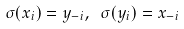<formula> <loc_0><loc_0><loc_500><loc_500>\sigma ( x _ { i } ) = y _ { - i } , \ \sigma ( y _ { i } ) = x _ { - i }</formula> 